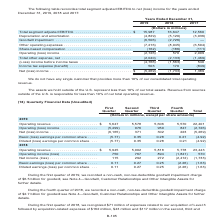According to Centurylink's financial document, What is the total operating revenue recorded in 2019? According to the financial document, 22,401 (in millions). The relevant text states: "019 Operating revenue . $ 5,647 5,578 5,606 5,570 22,401 Operating (loss) income . (5,499) 976 950 847 (2,726) Net (loss) income . (6,165) 371 302 223 (5,26..." Also, What is the total Operating (loss) income recorded in 2018? According to the financial document, 570 (in millions). The relevant text states: "Operating (loss) income . (2,726) 570 2,009 Total other expense, net . (2,040) (2,133) (1,469)..." Also, In which periods was a non-cash, non-tax-deductible goodwill impairment charge recorded? The document shows two values: first quarter of 2019 and fourth quarter of 2018. From the document: "During the first quarter of 2019, we recorded a non-cash, non-tax-deductible goodwill impairment charge of $6.5 billion for goodwill During the fourth..." Additionally, Which quarter in 2019 has the largest operating revenue? According to the financial document, First Quarter. The relevant text states: "First Quarter..." Also, can you calculate: What is the total amount of expenses related to the acquisition of Level 3 recorded in 2019? Based on the calculation: 34+39+38+123, the result is 234 (in millions). This is based on the information: "Net (loss) income . $ (5,269) (1,733) 1,389..." The key data points involved are: 123, 38, 39. Also, can you calculate: What is the average quarterly amount of expenses related to the acquisition of Level 3 recorded in 2019? To answer this question, I need to perform calculations using the financial data. The calculation is: (34+39+38+123)/4, which equals 58.5 (in millions). This is based on the information: "Net (loss) income . $ (5,269) (1,733) 1,389..." The key data points involved are: 123, 34, 38. 